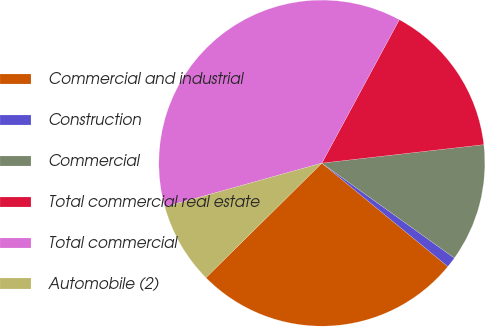Convert chart. <chart><loc_0><loc_0><loc_500><loc_500><pie_chart><fcel>Commercial and industrial<fcel>Construction<fcel>Commercial<fcel>Total commercial real estate<fcel>Total commercial<fcel>Automobile (2)<nl><fcel>26.65%<fcel>1.05%<fcel>11.7%<fcel>15.31%<fcel>37.21%<fcel>8.08%<nl></chart> 